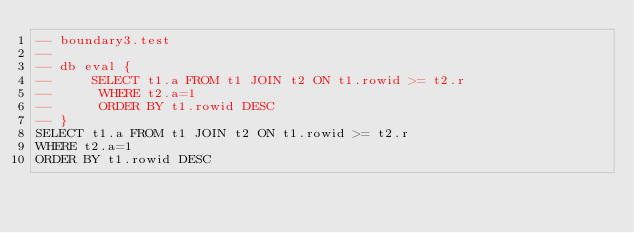<code> <loc_0><loc_0><loc_500><loc_500><_SQL_>-- boundary3.test
-- 
-- db eval {
--     SELECT t1.a FROM t1 JOIN t2 ON t1.rowid >= t2.r
--      WHERE t2.a=1
--      ORDER BY t1.rowid DESC
-- }
SELECT t1.a FROM t1 JOIN t2 ON t1.rowid >= t2.r
WHERE t2.a=1
ORDER BY t1.rowid DESC</code> 